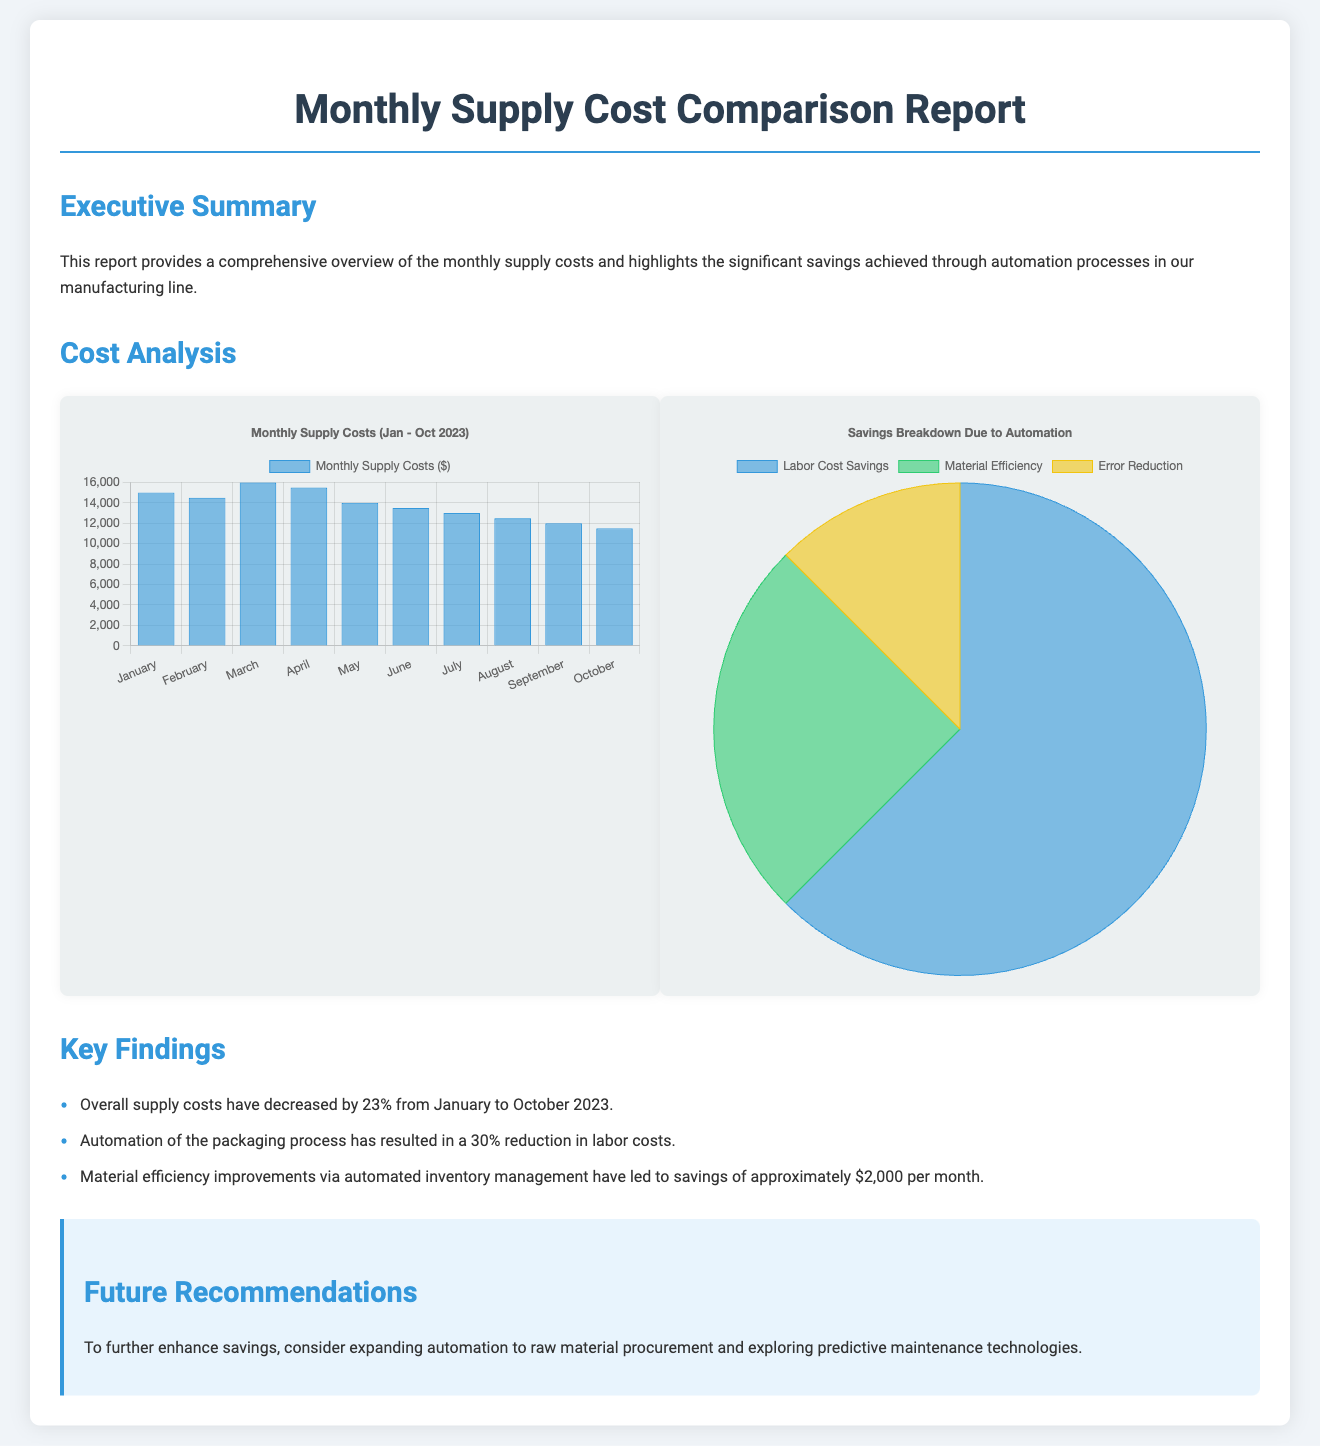What is the percentage decrease in overall supply costs from January to October 2023? The document states that overall supply costs have decreased by 23% from January to October 2023.
Answer: 23% What cost reduction percentage was achieved through automation of the packaging process? The report indicates that automation of the packaging process has resulted in a 30% reduction in labor costs.
Answer: 30% How much savings per month was achieved through material efficiency improvements? The document mentions that material efficiency improvements led to savings of approximately $2,000 per month.
Answer: $2000 What is the title of the first chart displayed in the report? The first chart displays the title "Monthly Supply Costs (Jan - Oct 2023)."
Answer: Monthly Supply Costs (Jan - Oct 2023) What is the total savings breakdown due to automation in labor cost savings? The savings chart indicates that labor cost savings amount to $5,000.
Answer: $5000 What type of document is this? The structure and contents of the document indicate that it is a Monthly Supply Cost Comparison Report.
Answer: Monthly Supply Cost Comparison Report What is the primary focus of the Executive Summary section? The Executive Summary provides an overview of monthly supply costs and savings achieved through automation processes.
Answer: Overview of monthly supply costs and savings through automation What are two future recommendations suggested in the report? The report recommends expanding automation to raw material procurement and exploring predictive maintenance technologies.
Answer: Expand automation and explore predictive maintenance technologies 